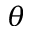<formula> <loc_0><loc_0><loc_500><loc_500>\theta</formula> 